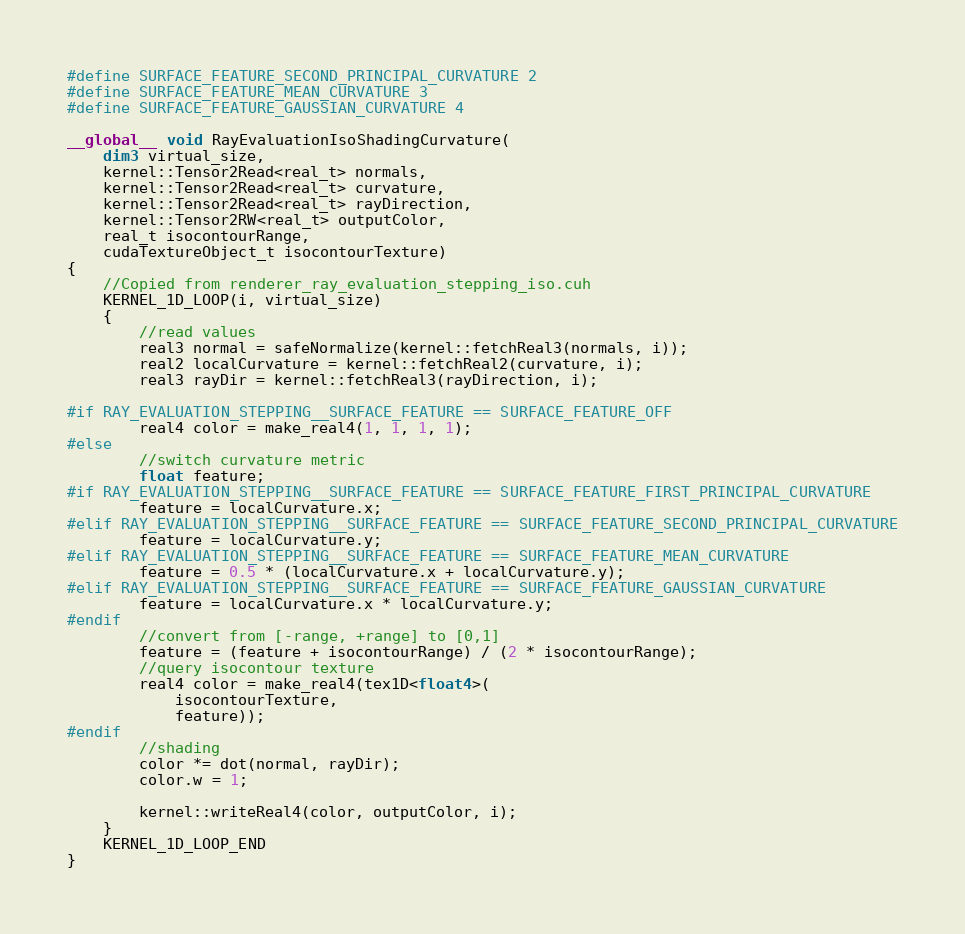Convert code to text. <code><loc_0><loc_0><loc_500><loc_500><_Cuda_>#define SURFACE_FEATURE_SECOND_PRINCIPAL_CURVATURE 2
#define SURFACE_FEATURE_MEAN_CURVATURE 3
#define SURFACE_FEATURE_GAUSSIAN_CURVATURE 4

__global__ void RayEvaluationIsoShadingCurvature(
    dim3 virtual_size,
    kernel::Tensor2Read<real_t> normals,
    kernel::Tensor2Read<real_t> curvature,
    kernel::Tensor2Read<real_t> rayDirection,
    kernel::Tensor2RW<real_t> outputColor,
    real_t isocontourRange,
    cudaTextureObject_t isocontourTexture)
{
    //Copied from renderer_ray_evaluation_stepping_iso.cuh
    KERNEL_1D_LOOP(i, virtual_size)
    {
		//read values
		real3 normal = safeNormalize(kernel::fetchReal3(normals, i));
		real2 localCurvature = kernel::fetchReal2(curvature, i);
		real3 rayDir = kernel::fetchReal3(rayDirection, i);

#if RAY_EVALUATION_STEPPING__SURFACE_FEATURE == SURFACE_FEATURE_OFF
		real4 color = make_real4(1, 1, 1, 1);
#else
		//switch curvature metric
		float feature;
#if RAY_EVALUATION_STEPPING__SURFACE_FEATURE == SURFACE_FEATURE_FIRST_PRINCIPAL_CURVATURE
		feature = localCurvature.x;
#elif RAY_EVALUATION_STEPPING__SURFACE_FEATURE == SURFACE_FEATURE_SECOND_PRINCIPAL_CURVATURE
		feature = localCurvature.y;
#elif RAY_EVALUATION_STEPPING__SURFACE_FEATURE == SURFACE_FEATURE_MEAN_CURVATURE
		feature = 0.5 * (localCurvature.x + localCurvature.y);
#elif RAY_EVALUATION_STEPPING__SURFACE_FEATURE == SURFACE_FEATURE_GAUSSIAN_CURVATURE
		feature = localCurvature.x * localCurvature.y;
#endif
		//convert from [-range, +range] to [0,1]
		feature = (feature + isocontourRange) / (2 * isocontourRange);
		//query isocontour texture
		real4 color = make_real4(tex1D<float4>(
			isocontourTexture,
			feature));
#endif
		//shading
		color *= dot(normal, rayDir);
		color.w = 1;

		kernel::writeReal4(color, outputColor, i);
    }
    KERNEL_1D_LOOP_END
}</code> 